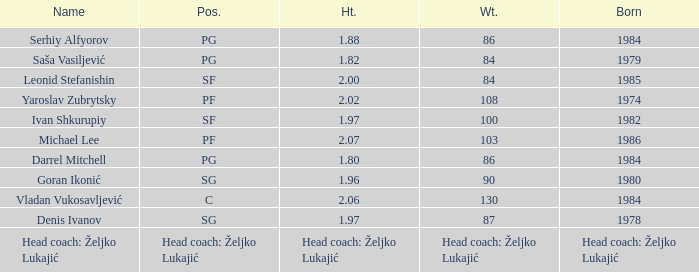What is the position of the player born in 1984 with a height of 1.80m? PG. 